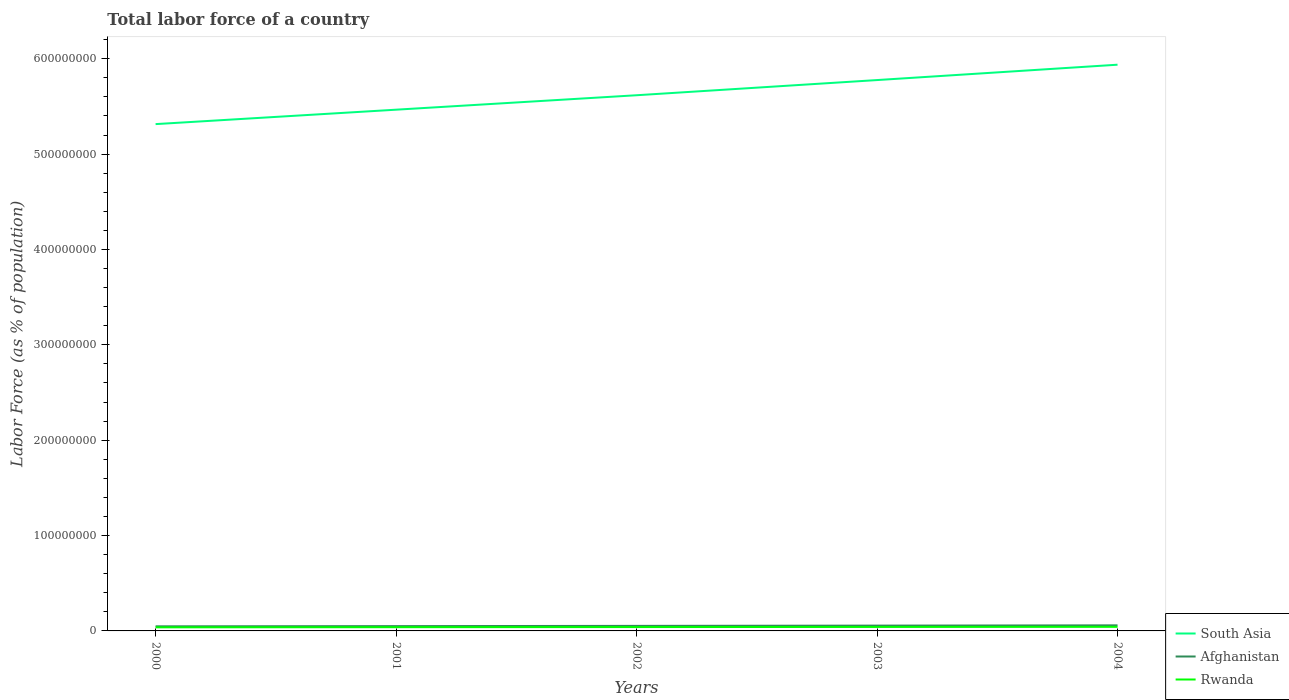How many different coloured lines are there?
Keep it short and to the point. 3. Does the line corresponding to Afghanistan intersect with the line corresponding to Rwanda?
Provide a succinct answer. No. Is the number of lines equal to the number of legend labels?
Your answer should be very brief. Yes. Across all years, what is the maximum percentage of labor force in South Asia?
Offer a terse response. 5.31e+08. What is the total percentage of labor force in South Asia in the graph?
Give a very brief answer. -4.62e+07. What is the difference between the highest and the second highest percentage of labor force in South Asia?
Your answer should be compact. 6.23e+07. How many years are there in the graph?
Keep it short and to the point. 5. What is the difference between two consecutive major ticks on the Y-axis?
Ensure brevity in your answer.  1.00e+08. Does the graph contain any zero values?
Give a very brief answer. No. Does the graph contain grids?
Provide a short and direct response. No. Where does the legend appear in the graph?
Offer a terse response. Bottom right. What is the title of the graph?
Ensure brevity in your answer.  Total labor force of a country. Does "Honduras" appear as one of the legend labels in the graph?
Make the answer very short. No. What is the label or title of the X-axis?
Ensure brevity in your answer.  Years. What is the label or title of the Y-axis?
Your response must be concise. Labor Force (as % of population). What is the Labor Force (as % of population) in South Asia in 2000?
Provide a succinct answer. 5.31e+08. What is the Labor Force (as % of population) in Afghanistan in 2000?
Give a very brief answer. 4.82e+06. What is the Labor Force (as % of population) of Rwanda in 2000?
Ensure brevity in your answer.  3.77e+06. What is the Labor Force (as % of population) in South Asia in 2001?
Your response must be concise. 5.47e+08. What is the Labor Force (as % of population) of Afghanistan in 2001?
Your answer should be compact. 5.03e+06. What is the Labor Force (as % of population) of Rwanda in 2001?
Offer a terse response. 3.92e+06. What is the Labor Force (as % of population) of South Asia in 2002?
Your answer should be very brief. 5.62e+08. What is the Labor Force (as % of population) in Afghanistan in 2002?
Your answer should be compact. 5.29e+06. What is the Labor Force (as % of population) of Rwanda in 2002?
Your answer should be compact. 4.05e+06. What is the Labor Force (as % of population) of South Asia in 2003?
Keep it short and to the point. 5.78e+08. What is the Labor Force (as % of population) in Afghanistan in 2003?
Offer a very short reply. 5.57e+06. What is the Labor Force (as % of population) of Rwanda in 2003?
Offer a very short reply. 4.17e+06. What is the Labor Force (as % of population) of South Asia in 2004?
Provide a short and direct response. 5.94e+08. What is the Labor Force (as % of population) in Afghanistan in 2004?
Your answer should be compact. 5.85e+06. What is the Labor Force (as % of population) of Rwanda in 2004?
Make the answer very short. 4.29e+06. Across all years, what is the maximum Labor Force (as % of population) in South Asia?
Give a very brief answer. 5.94e+08. Across all years, what is the maximum Labor Force (as % of population) in Afghanistan?
Provide a short and direct response. 5.85e+06. Across all years, what is the maximum Labor Force (as % of population) in Rwanda?
Provide a succinct answer. 4.29e+06. Across all years, what is the minimum Labor Force (as % of population) of South Asia?
Keep it short and to the point. 5.31e+08. Across all years, what is the minimum Labor Force (as % of population) in Afghanistan?
Your response must be concise. 4.82e+06. Across all years, what is the minimum Labor Force (as % of population) in Rwanda?
Keep it short and to the point. 3.77e+06. What is the total Labor Force (as % of population) in South Asia in the graph?
Give a very brief answer. 2.81e+09. What is the total Labor Force (as % of population) of Afghanistan in the graph?
Provide a short and direct response. 2.66e+07. What is the total Labor Force (as % of population) of Rwanda in the graph?
Ensure brevity in your answer.  2.02e+07. What is the difference between the Labor Force (as % of population) in South Asia in 2000 and that in 2001?
Your answer should be very brief. -1.51e+07. What is the difference between the Labor Force (as % of population) in Afghanistan in 2000 and that in 2001?
Keep it short and to the point. -2.09e+05. What is the difference between the Labor Force (as % of population) in Rwanda in 2000 and that in 2001?
Keep it short and to the point. -1.46e+05. What is the difference between the Labor Force (as % of population) of South Asia in 2000 and that in 2002?
Keep it short and to the point. -3.03e+07. What is the difference between the Labor Force (as % of population) in Afghanistan in 2000 and that in 2002?
Your answer should be very brief. -4.70e+05. What is the difference between the Labor Force (as % of population) in Rwanda in 2000 and that in 2002?
Ensure brevity in your answer.  -2.78e+05. What is the difference between the Labor Force (as % of population) in South Asia in 2000 and that in 2003?
Make the answer very short. -4.62e+07. What is the difference between the Labor Force (as % of population) of Afghanistan in 2000 and that in 2003?
Keep it short and to the point. -7.45e+05. What is the difference between the Labor Force (as % of population) in Rwanda in 2000 and that in 2003?
Offer a very short reply. -4.02e+05. What is the difference between the Labor Force (as % of population) in South Asia in 2000 and that in 2004?
Provide a short and direct response. -6.23e+07. What is the difference between the Labor Force (as % of population) of Afghanistan in 2000 and that in 2004?
Your answer should be compact. -1.03e+06. What is the difference between the Labor Force (as % of population) of Rwanda in 2000 and that in 2004?
Make the answer very short. -5.17e+05. What is the difference between the Labor Force (as % of population) of South Asia in 2001 and that in 2002?
Offer a terse response. -1.51e+07. What is the difference between the Labor Force (as % of population) in Afghanistan in 2001 and that in 2002?
Keep it short and to the point. -2.62e+05. What is the difference between the Labor Force (as % of population) of Rwanda in 2001 and that in 2002?
Offer a terse response. -1.32e+05. What is the difference between the Labor Force (as % of population) of South Asia in 2001 and that in 2003?
Give a very brief answer. -3.11e+07. What is the difference between the Labor Force (as % of population) in Afghanistan in 2001 and that in 2003?
Offer a very short reply. -5.36e+05. What is the difference between the Labor Force (as % of population) of Rwanda in 2001 and that in 2003?
Provide a succinct answer. -2.56e+05. What is the difference between the Labor Force (as % of population) of South Asia in 2001 and that in 2004?
Provide a succinct answer. -4.72e+07. What is the difference between the Labor Force (as % of population) in Afghanistan in 2001 and that in 2004?
Ensure brevity in your answer.  -8.22e+05. What is the difference between the Labor Force (as % of population) in Rwanda in 2001 and that in 2004?
Ensure brevity in your answer.  -3.71e+05. What is the difference between the Labor Force (as % of population) in South Asia in 2002 and that in 2003?
Provide a succinct answer. -1.59e+07. What is the difference between the Labor Force (as % of population) of Afghanistan in 2002 and that in 2003?
Your answer should be very brief. -2.75e+05. What is the difference between the Labor Force (as % of population) in Rwanda in 2002 and that in 2003?
Keep it short and to the point. -1.24e+05. What is the difference between the Labor Force (as % of population) of South Asia in 2002 and that in 2004?
Make the answer very short. -3.20e+07. What is the difference between the Labor Force (as % of population) of Afghanistan in 2002 and that in 2004?
Provide a short and direct response. -5.60e+05. What is the difference between the Labor Force (as % of population) of Rwanda in 2002 and that in 2004?
Offer a terse response. -2.39e+05. What is the difference between the Labor Force (as % of population) of South Asia in 2003 and that in 2004?
Keep it short and to the point. -1.61e+07. What is the difference between the Labor Force (as % of population) in Afghanistan in 2003 and that in 2004?
Provide a short and direct response. -2.86e+05. What is the difference between the Labor Force (as % of population) in Rwanda in 2003 and that in 2004?
Your answer should be compact. -1.15e+05. What is the difference between the Labor Force (as % of population) in South Asia in 2000 and the Labor Force (as % of population) in Afghanistan in 2001?
Ensure brevity in your answer.  5.26e+08. What is the difference between the Labor Force (as % of population) of South Asia in 2000 and the Labor Force (as % of population) of Rwanda in 2001?
Keep it short and to the point. 5.28e+08. What is the difference between the Labor Force (as % of population) in Afghanistan in 2000 and the Labor Force (as % of population) in Rwanda in 2001?
Your response must be concise. 9.07e+05. What is the difference between the Labor Force (as % of population) of South Asia in 2000 and the Labor Force (as % of population) of Afghanistan in 2002?
Your response must be concise. 5.26e+08. What is the difference between the Labor Force (as % of population) of South Asia in 2000 and the Labor Force (as % of population) of Rwanda in 2002?
Make the answer very short. 5.27e+08. What is the difference between the Labor Force (as % of population) in Afghanistan in 2000 and the Labor Force (as % of population) in Rwanda in 2002?
Your answer should be very brief. 7.75e+05. What is the difference between the Labor Force (as % of population) in South Asia in 2000 and the Labor Force (as % of population) in Afghanistan in 2003?
Give a very brief answer. 5.26e+08. What is the difference between the Labor Force (as % of population) in South Asia in 2000 and the Labor Force (as % of population) in Rwanda in 2003?
Give a very brief answer. 5.27e+08. What is the difference between the Labor Force (as % of population) of Afghanistan in 2000 and the Labor Force (as % of population) of Rwanda in 2003?
Provide a succinct answer. 6.51e+05. What is the difference between the Labor Force (as % of population) in South Asia in 2000 and the Labor Force (as % of population) in Afghanistan in 2004?
Give a very brief answer. 5.26e+08. What is the difference between the Labor Force (as % of population) in South Asia in 2000 and the Labor Force (as % of population) in Rwanda in 2004?
Keep it short and to the point. 5.27e+08. What is the difference between the Labor Force (as % of population) in Afghanistan in 2000 and the Labor Force (as % of population) in Rwanda in 2004?
Ensure brevity in your answer.  5.36e+05. What is the difference between the Labor Force (as % of population) of South Asia in 2001 and the Labor Force (as % of population) of Afghanistan in 2002?
Offer a very short reply. 5.41e+08. What is the difference between the Labor Force (as % of population) of South Asia in 2001 and the Labor Force (as % of population) of Rwanda in 2002?
Your response must be concise. 5.42e+08. What is the difference between the Labor Force (as % of population) of Afghanistan in 2001 and the Labor Force (as % of population) of Rwanda in 2002?
Keep it short and to the point. 9.83e+05. What is the difference between the Labor Force (as % of population) in South Asia in 2001 and the Labor Force (as % of population) in Afghanistan in 2003?
Give a very brief answer. 5.41e+08. What is the difference between the Labor Force (as % of population) of South Asia in 2001 and the Labor Force (as % of population) of Rwanda in 2003?
Make the answer very short. 5.42e+08. What is the difference between the Labor Force (as % of population) of Afghanistan in 2001 and the Labor Force (as % of population) of Rwanda in 2003?
Your answer should be compact. 8.60e+05. What is the difference between the Labor Force (as % of population) of South Asia in 2001 and the Labor Force (as % of population) of Afghanistan in 2004?
Offer a very short reply. 5.41e+08. What is the difference between the Labor Force (as % of population) in South Asia in 2001 and the Labor Force (as % of population) in Rwanda in 2004?
Give a very brief answer. 5.42e+08. What is the difference between the Labor Force (as % of population) in Afghanistan in 2001 and the Labor Force (as % of population) in Rwanda in 2004?
Your answer should be very brief. 7.44e+05. What is the difference between the Labor Force (as % of population) in South Asia in 2002 and the Labor Force (as % of population) in Afghanistan in 2003?
Offer a terse response. 5.56e+08. What is the difference between the Labor Force (as % of population) in South Asia in 2002 and the Labor Force (as % of population) in Rwanda in 2003?
Keep it short and to the point. 5.58e+08. What is the difference between the Labor Force (as % of population) in Afghanistan in 2002 and the Labor Force (as % of population) in Rwanda in 2003?
Offer a terse response. 1.12e+06. What is the difference between the Labor Force (as % of population) of South Asia in 2002 and the Labor Force (as % of population) of Afghanistan in 2004?
Provide a succinct answer. 5.56e+08. What is the difference between the Labor Force (as % of population) in South Asia in 2002 and the Labor Force (as % of population) in Rwanda in 2004?
Your answer should be very brief. 5.57e+08. What is the difference between the Labor Force (as % of population) in Afghanistan in 2002 and the Labor Force (as % of population) in Rwanda in 2004?
Your answer should be compact. 1.01e+06. What is the difference between the Labor Force (as % of population) in South Asia in 2003 and the Labor Force (as % of population) in Afghanistan in 2004?
Offer a very short reply. 5.72e+08. What is the difference between the Labor Force (as % of population) of South Asia in 2003 and the Labor Force (as % of population) of Rwanda in 2004?
Give a very brief answer. 5.73e+08. What is the difference between the Labor Force (as % of population) of Afghanistan in 2003 and the Labor Force (as % of population) of Rwanda in 2004?
Ensure brevity in your answer.  1.28e+06. What is the average Labor Force (as % of population) in South Asia per year?
Provide a short and direct response. 5.62e+08. What is the average Labor Force (as % of population) in Afghanistan per year?
Ensure brevity in your answer.  5.31e+06. What is the average Labor Force (as % of population) of Rwanda per year?
Your response must be concise. 4.04e+06. In the year 2000, what is the difference between the Labor Force (as % of population) in South Asia and Labor Force (as % of population) in Afghanistan?
Your response must be concise. 5.27e+08. In the year 2000, what is the difference between the Labor Force (as % of population) in South Asia and Labor Force (as % of population) in Rwanda?
Your answer should be very brief. 5.28e+08. In the year 2000, what is the difference between the Labor Force (as % of population) in Afghanistan and Labor Force (as % of population) in Rwanda?
Give a very brief answer. 1.05e+06. In the year 2001, what is the difference between the Labor Force (as % of population) in South Asia and Labor Force (as % of population) in Afghanistan?
Ensure brevity in your answer.  5.42e+08. In the year 2001, what is the difference between the Labor Force (as % of population) of South Asia and Labor Force (as % of population) of Rwanda?
Your answer should be very brief. 5.43e+08. In the year 2001, what is the difference between the Labor Force (as % of population) in Afghanistan and Labor Force (as % of population) in Rwanda?
Your answer should be compact. 1.12e+06. In the year 2002, what is the difference between the Labor Force (as % of population) of South Asia and Labor Force (as % of population) of Afghanistan?
Provide a succinct answer. 5.56e+08. In the year 2002, what is the difference between the Labor Force (as % of population) of South Asia and Labor Force (as % of population) of Rwanda?
Keep it short and to the point. 5.58e+08. In the year 2002, what is the difference between the Labor Force (as % of population) in Afghanistan and Labor Force (as % of population) in Rwanda?
Offer a very short reply. 1.25e+06. In the year 2003, what is the difference between the Labor Force (as % of population) in South Asia and Labor Force (as % of population) in Afghanistan?
Offer a terse response. 5.72e+08. In the year 2003, what is the difference between the Labor Force (as % of population) of South Asia and Labor Force (as % of population) of Rwanda?
Provide a short and direct response. 5.73e+08. In the year 2003, what is the difference between the Labor Force (as % of population) of Afghanistan and Labor Force (as % of population) of Rwanda?
Provide a short and direct response. 1.40e+06. In the year 2004, what is the difference between the Labor Force (as % of population) of South Asia and Labor Force (as % of population) of Afghanistan?
Offer a very short reply. 5.88e+08. In the year 2004, what is the difference between the Labor Force (as % of population) in South Asia and Labor Force (as % of population) in Rwanda?
Make the answer very short. 5.89e+08. In the year 2004, what is the difference between the Labor Force (as % of population) in Afghanistan and Labor Force (as % of population) in Rwanda?
Provide a short and direct response. 1.57e+06. What is the ratio of the Labor Force (as % of population) in South Asia in 2000 to that in 2001?
Make the answer very short. 0.97. What is the ratio of the Labor Force (as % of population) of Afghanistan in 2000 to that in 2001?
Provide a short and direct response. 0.96. What is the ratio of the Labor Force (as % of population) of Rwanda in 2000 to that in 2001?
Your answer should be compact. 0.96. What is the ratio of the Labor Force (as % of population) in South Asia in 2000 to that in 2002?
Offer a terse response. 0.95. What is the ratio of the Labor Force (as % of population) of Afghanistan in 2000 to that in 2002?
Give a very brief answer. 0.91. What is the ratio of the Labor Force (as % of population) of Rwanda in 2000 to that in 2002?
Offer a very short reply. 0.93. What is the ratio of the Labor Force (as % of population) of Afghanistan in 2000 to that in 2003?
Your answer should be compact. 0.87. What is the ratio of the Labor Force (as % of population) of Rwanda in 2000 to that in 2003?
Provide a short and direct response. 0.9. What is the ratio of the Labor Force (as % of population) of South Asia in 2000 to that in 2004?
Provide a succinct answer. 0.9. What is the ratio of the Labor Force (as % of population) in Afghanistan in 2000 to that in 2004?
Provide a succinct answer. 0.82. What is the ratio of the Labor Force (as % of population) of Rwanda in 2000 to that in 2004?
Keep it short and to the point. 0.88. What is the ratio of the Labor Force (as % of population) in South Asia in 2001 to that in 2002?
Ensure brevity in your answer.  0.97. What is the ratio of the Labor Force (as % of population) of Afghanistan in 2001 to that in 2002?
Your answer should be compact. 0.95. What is the ratio of the Labor Force (as % of population) in Rwanda in 2001 to that in 2002?
Your answer should be compact. 0.97. What is the ratio of the Labor Force (as % of population) of South Asia in 2001 to that in 2003?
Your answer should be very brief. 0.95. What is the ratio of the Labor Force (as % of population) of Afghanistan in 2001 to that in 2003?
Your response must be concise. 0.9. What is the ratio of the Labor Force (as % of population) of Rwanda in 2001 to that in 2003?
Offer a very short reply. 0.94. What is the ratio of the Labor Force (as % of population) of South Asia in 2001 to that in 2004?
Make the answer very short. 0.92. What is the ratio of the Labor Force (as % of population) in Afghanistan in 2001 to that in 2004?
Offer a very short reply. 0.86. What is the ratio of the Labor Force (as % of population) of Rwanda in 2001 to that in 2004?
Ensure brevity in your answer.  0.91. What is the ratio of the Labor Force (as % of population) of South Asia in 2002 to that in 2003?
Provide a short and direct response. 0.97. What is the ratio of the Labor Force (as % of population) of Afghanistan in 2002 to that in 2003?
Give a very brief answer. 0.95. What is the ratio of the Labor Force (as % of population) in Rwanda in 2002 to that in 2003?
Provide a short and direct response. 0.97. What is the ratio of the Labor Force (as % of population) in South Asia in 2002 to that in 2004?
Offer a very short reply. 0.95. What is the ratio of the Labor Force (as % of population) of Afghanistan in 2002 to that in 2004?
Offer a terse response. 0.9. What is the ratio of the Labor Force (as % of population) of Rwanda in 2002 to that in 2004?
Provide a succinct answer. 0.94. What is the ratio of the Labor Force (as % of population) of South Asia in 2003 to that in 2004?
Your response must be concise. 0.97. What is the ratio of the Labor Force (as % of population) of Afghanistan in 2003 to that in 2004?
Provide a succinct answer. 0.95. What is the ratio of the Labor Force (as % of population) in Rwanda in 2003 to that in 2004?
Your response must be concise. 0.97. What is the difference between the highest and the second highest Labor Force (as % of population) of South Asia?
Your response must be concise. 1.61e+07. What is the difference between the highest and the second highest Labor Force (as % of population) in Afghanistan?
Your answer should be very brief. 2.86e+05. What is the difference between the highest and the second highest Labor Force (as % of population) of Rwanda?
Provide a succinct answer. 1.15e+05. What is the difference between the highest and the lowest Labor Force (as % of population) of South Asia?
Make the answer very short. 6.23e+07. What is the difference between the highest and the lowest Labor Force (as % of population) of Afghanistan?
Offer a very short reply. 1.03e+06. What is the difference between the highest and the lowest Labor Force (as % of population) of Rwanda?
Offer a terse response. 5.17e+05. 